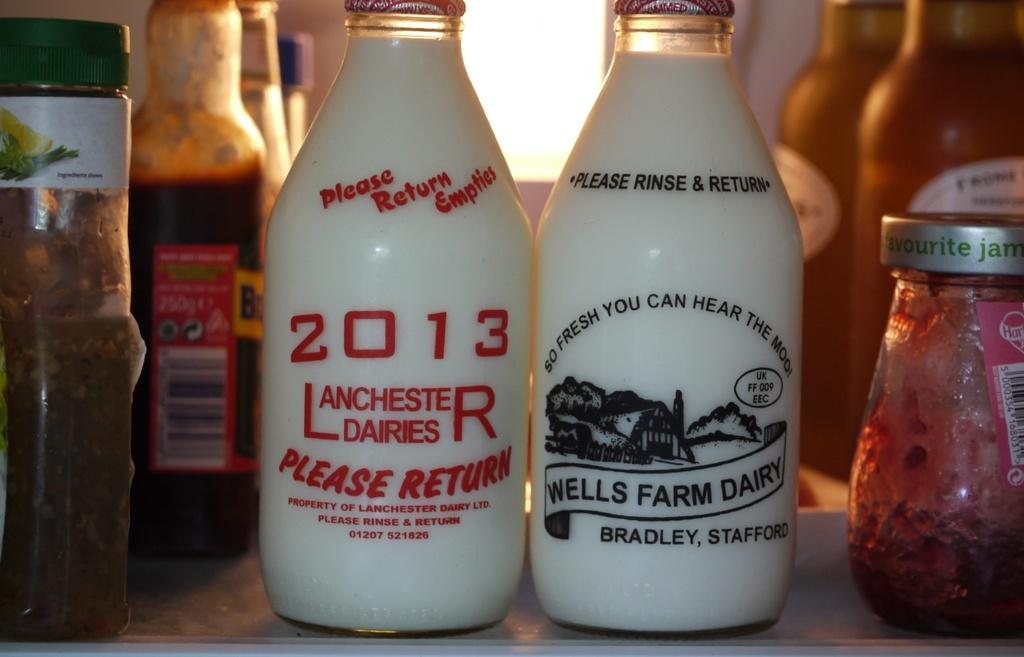<image>
Present a compact description of the photo's key features. Two bottles of white liquid from Wells Farm Dairy. 